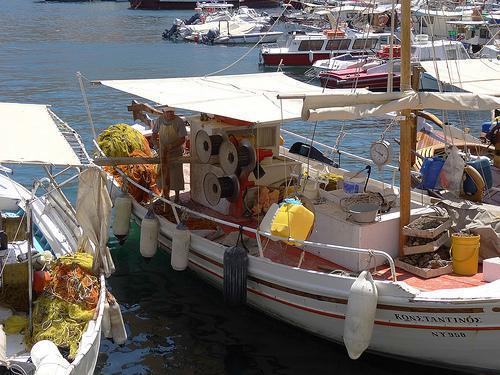How many people are the boat?
Give a very brief answer. 1. 